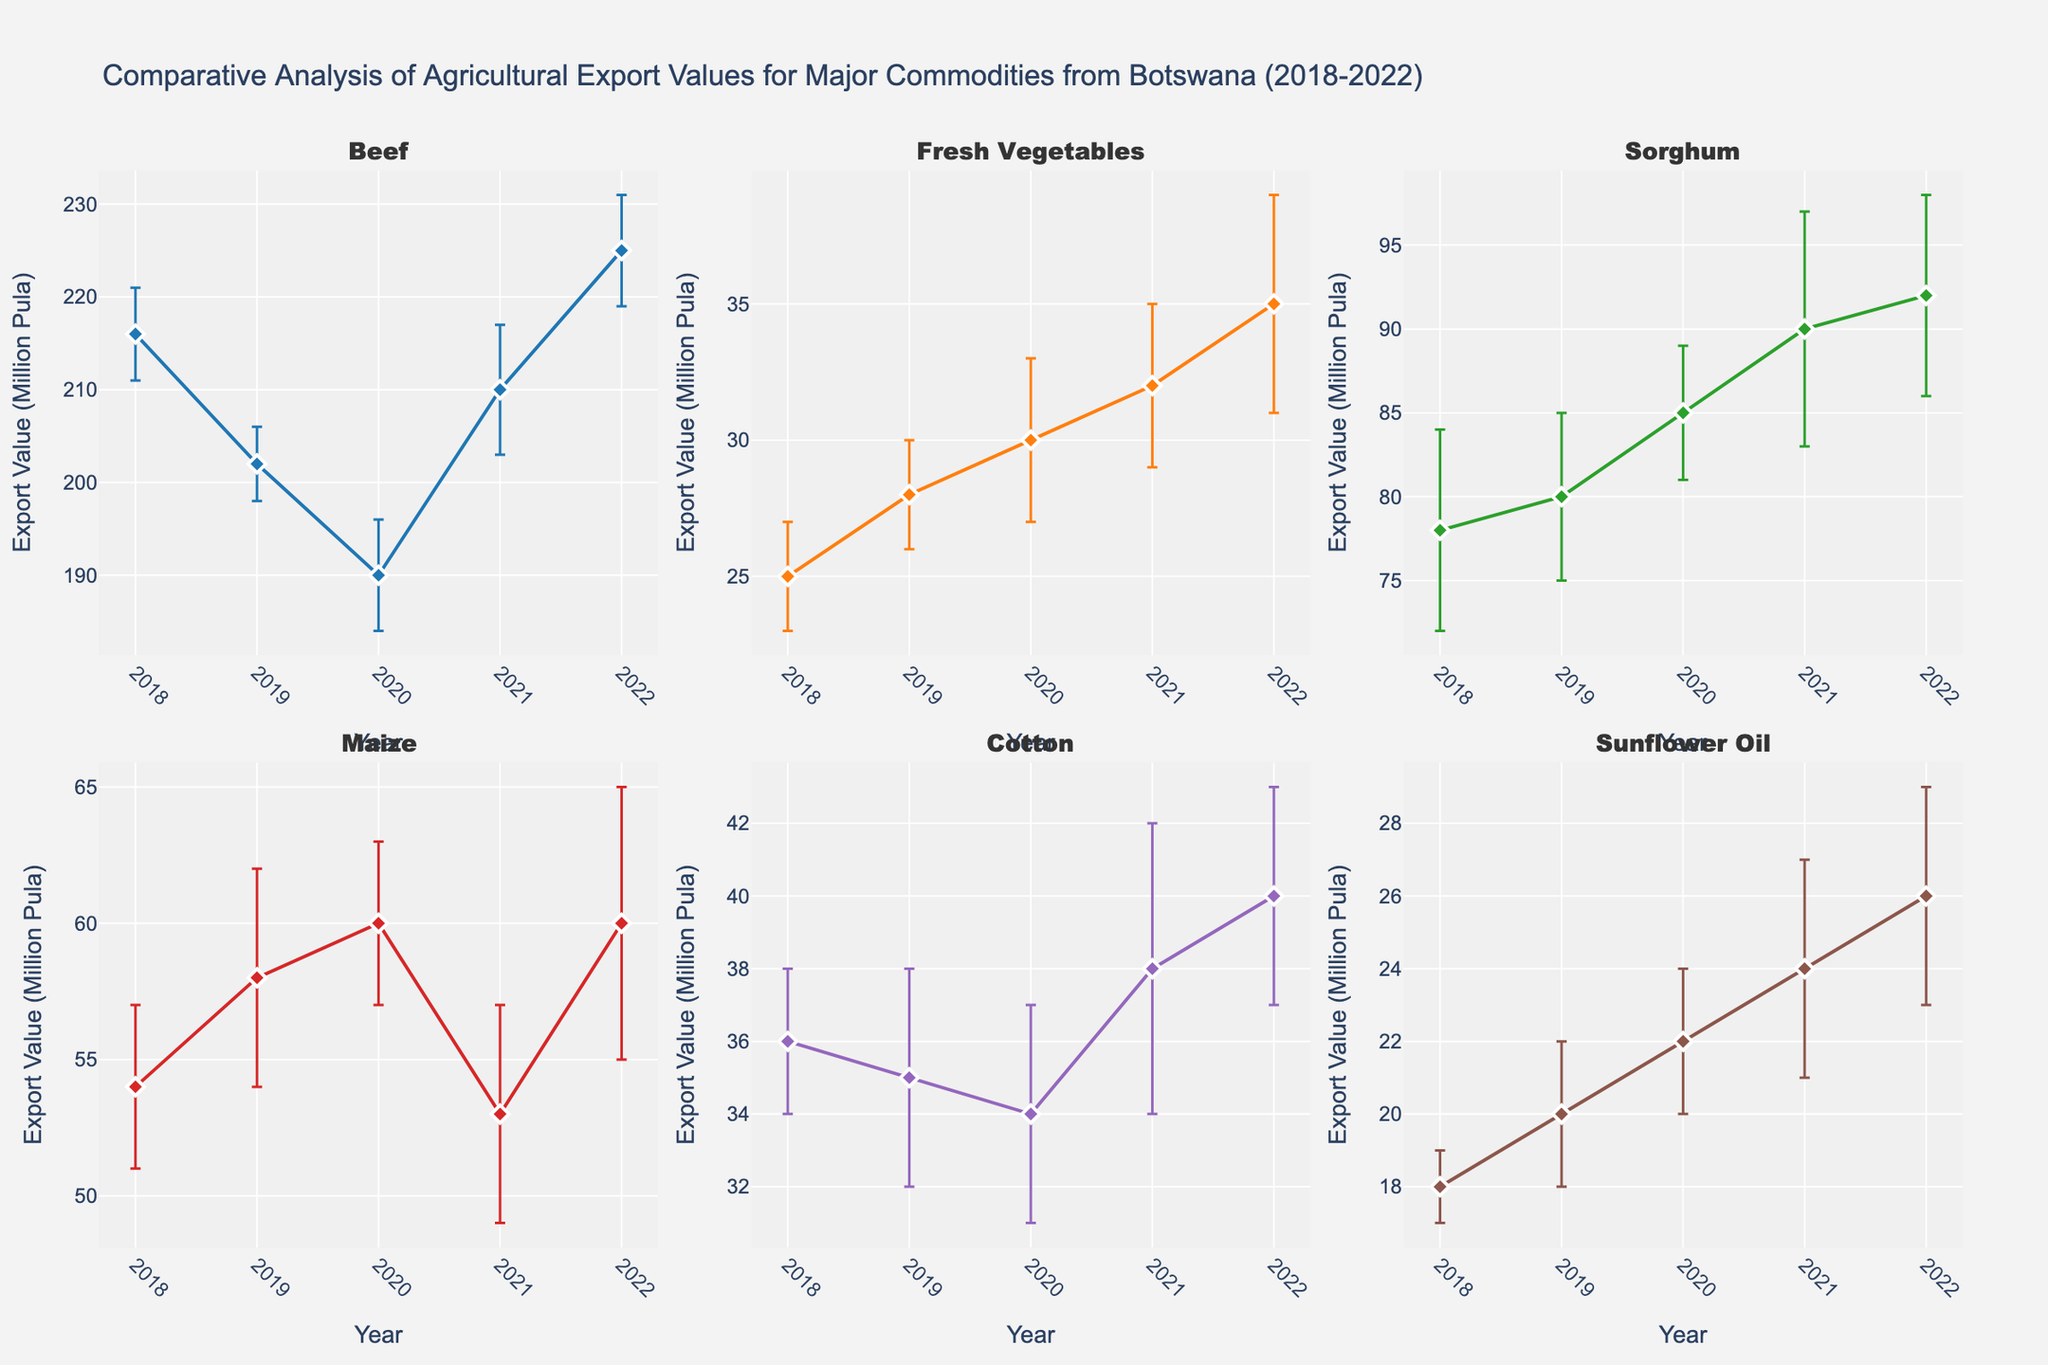what is the title of the figure? The title of the figure is displayed at the top. It reads "Comparative Analysis of Agricultural Export Values for Major Commodities from Botswana (2018-2022)".
Answer: Comparative Analysis of Agricultural Export Values for Major Commodities from Botswana (2018-2022) Which commodity has the highest export value in 2022? By looking at the individual subplots for each commodity and focusing on the year 2022, the data points show that Beef has the highest export value.
Answer: Beef How does the export value of Maize in 2018 compare to that in 2021? The subplot for Maize shows that the export value in 2018 is 54 Million Pula and in 2021 it is 53 Million Pula. The 2021 value is slightly lower than the 2018 value.
Answer: Lower What is the overall trend in the export value of Fresh Vegetables from 2018 to 2022? Observing the subplot for Fresh Vegetables, the export values are increasing year by year from 25 Million Pula in 2018 to 35 Million Pula in 2022. This indicates an upward trend.
Answer: Increasing Which commodity shows the least variation in export values over the years 2018-2022? The variation in export values can be observed by looking at the error bars. Among the commodities, Sunflower Oil shows the smallest error bars throughout the years, indicating the least variation.
Answer: Sunflower Oil How does the export value of Cotton in 2020 compare to that in 2021? According to the subplot for Cotton, the export value in 2020 is 34 Million Pula and in 2021 it is 38 Million Pula. The 2021 export value is higher than the 2020 value.
Answer: Higher What is the difference in export values of Sorghum between 2018 and 2022? In the subplot for Sorghum, the export value in 2018 is 78 Million Pula and in 2022 it is 92 Million Pula. So, the difference is 92 - 78 = 14 Million Pula.
Answer: 14 Million Pula Which commodity had a decline in export value from 2019 to 2020? By examining each subplot from 2019 to 2020, we notice that Beef sees a decline in export value from 202 Million Pula to 190 Million Pula in that period.
Answer: Beef Which year does Maize show its lowest export value within 2018-2022? Reviewing the subplot for Maize, the lowest export value is seen in 2021 with 53 Million Pula.
Answer: 2021 